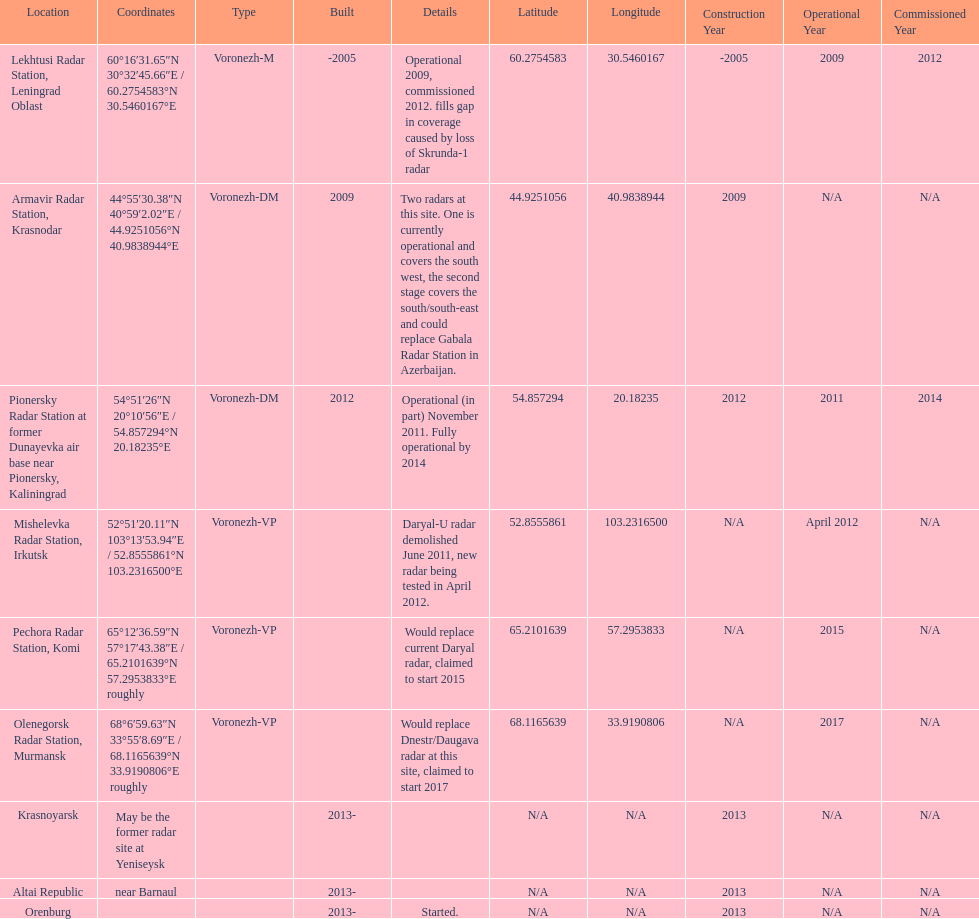How many voronezh radars were built before 2010? 2. 